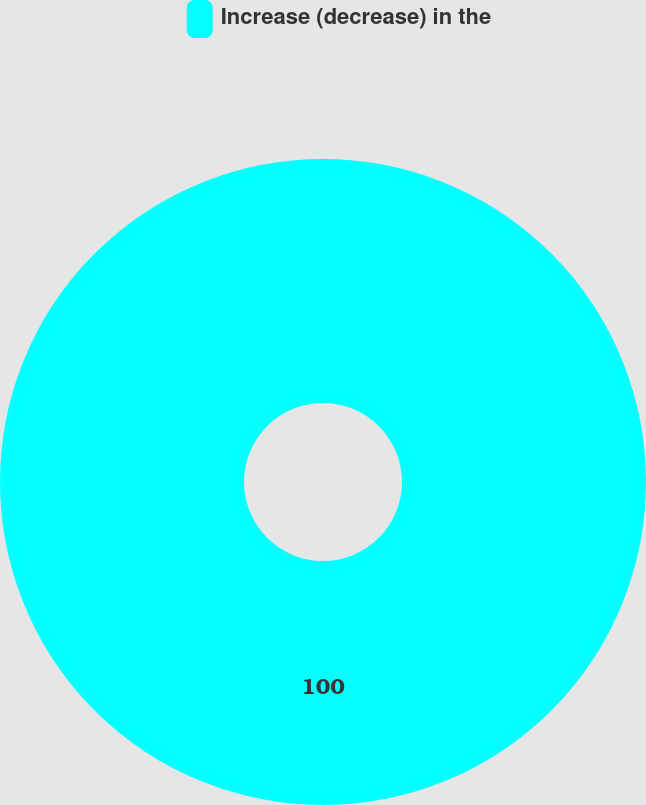<chart> <loc_0><loc_0><loc_500><loc_500><pie_chart><fcel>Increase (decrease) in the<nl><fcel>100.0%<nl></chart> 